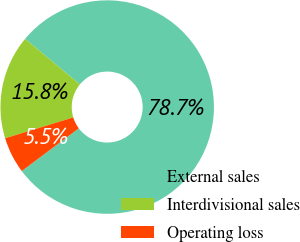<chart> <loc_0><loc_0><loc_500><loc_500><pie_chart><fcel>External sales<fcel>Interdivisional sales<fcel>Operating loss<nl><fcel>78.74%<fcel>15.75%<fcel>5.51%<nl></chart> 